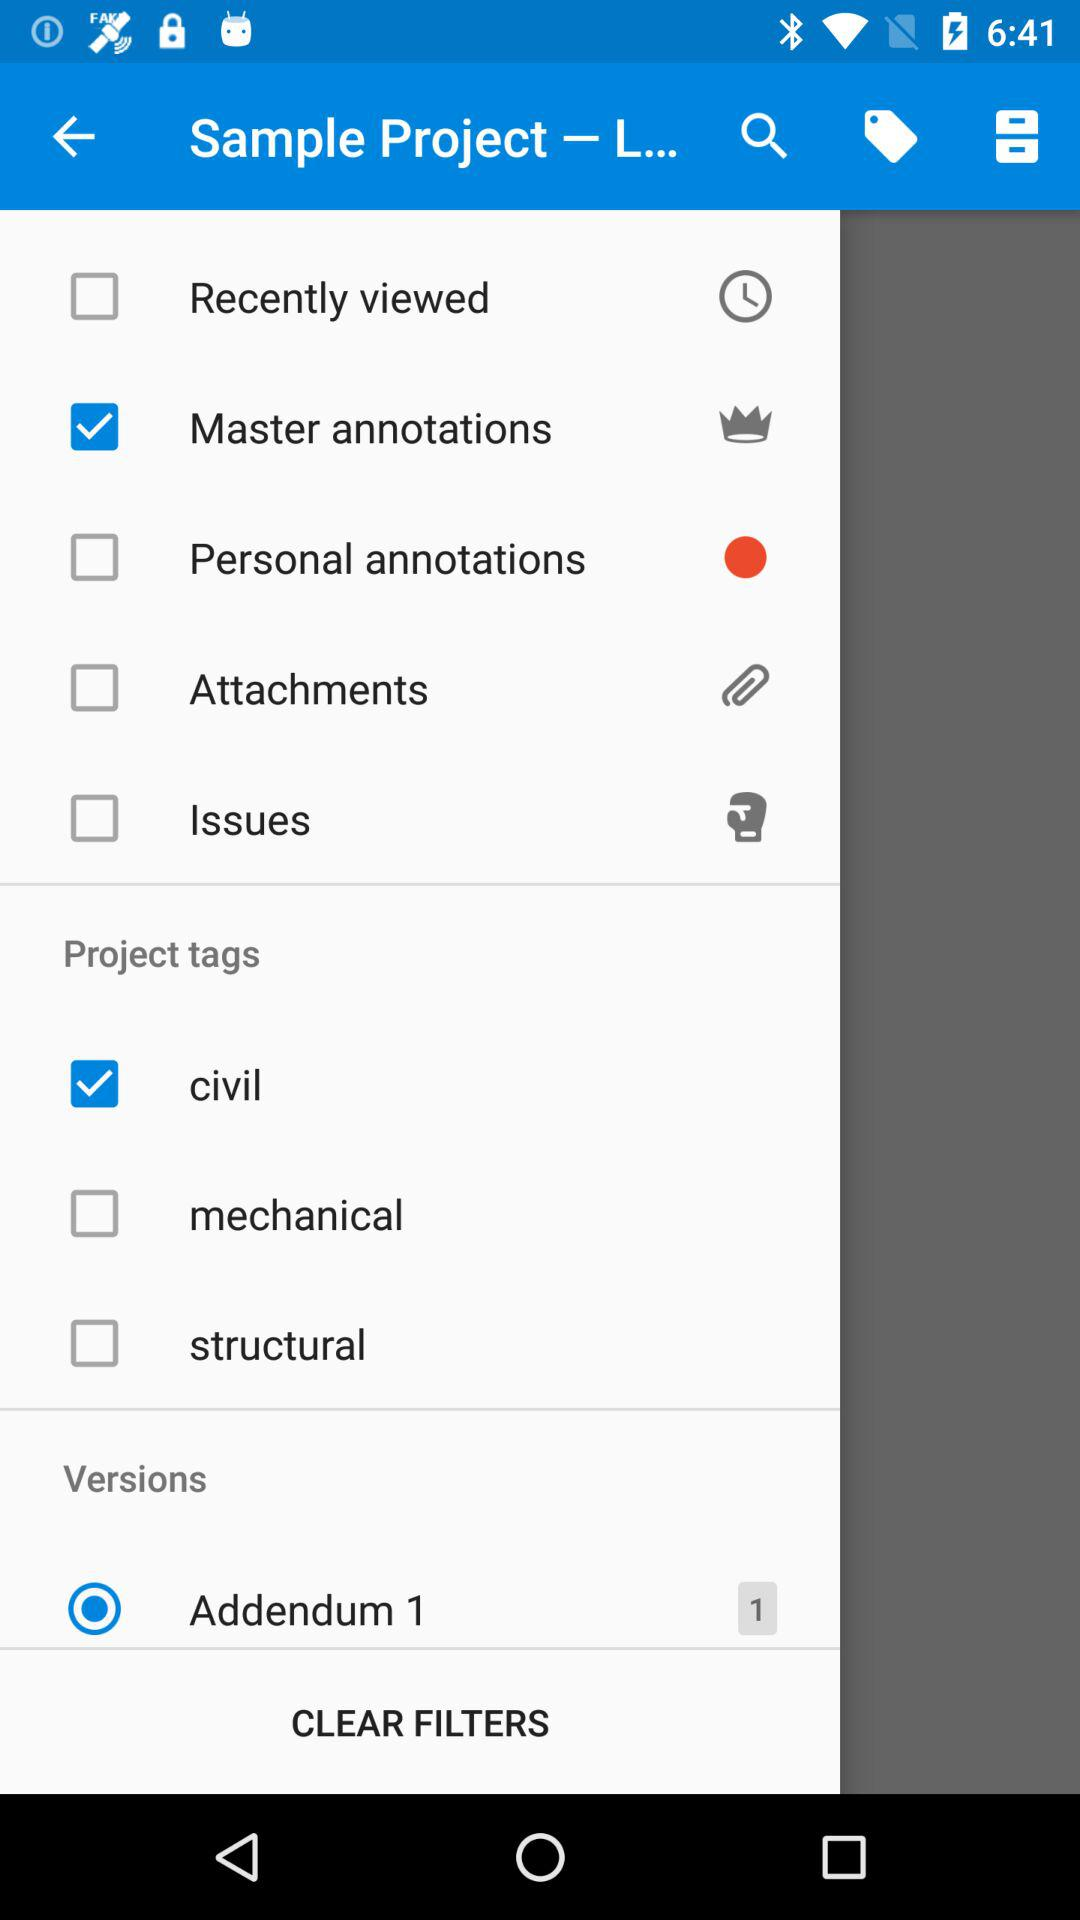What is the current status of the structural? The current status is "off". 